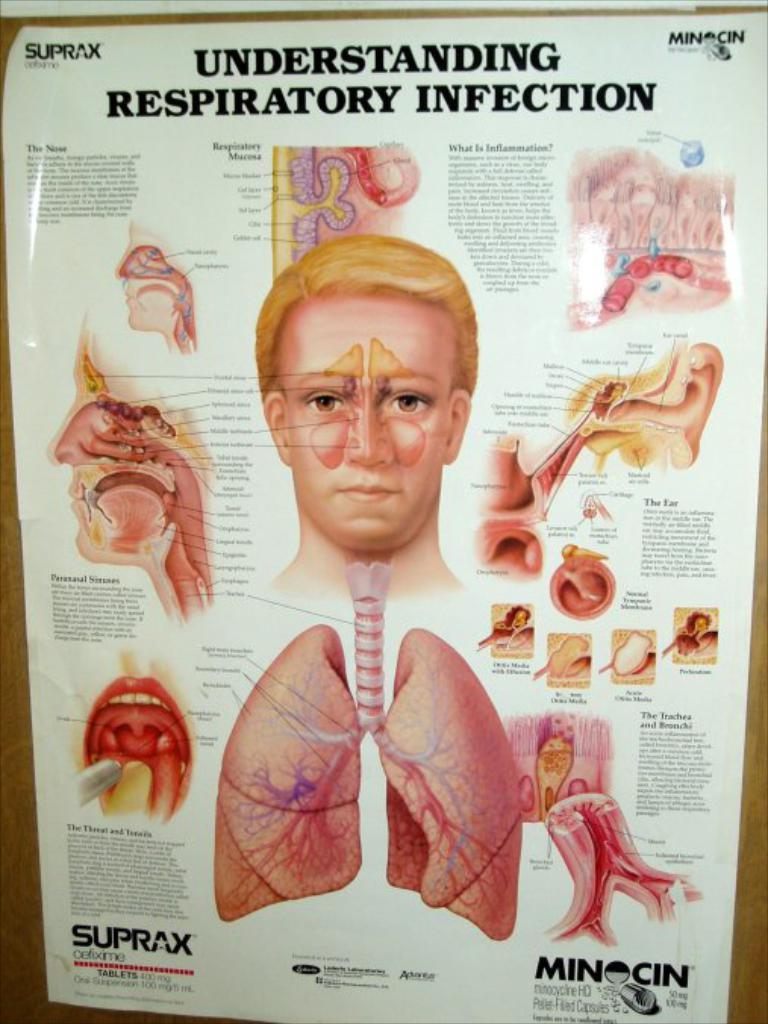What is present in the image? There is a poster in the image. What is depicted on the poster? The poster contains body parts of a person. Is there any text on the poster? Yes, there is text on the poster. What type of underwear is the person wearing in the image? There is no person wearing underwear in the image, as it only contains a poster with body parts. 